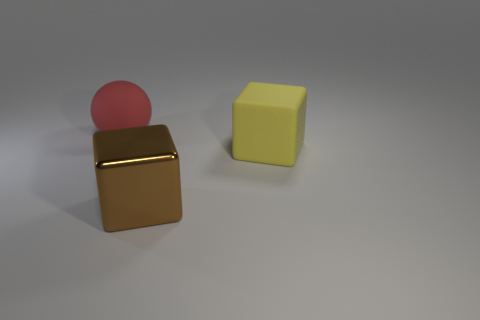How many red spheres are the same size as the yellow matte thing?
Offer a terse response. 1. Is the number of brown blocks that are on the right side of the yellow object the same as the number of large purple spheres?
Provide a short and direct response. Yes. How many large things are to the left of the yellow rubber object and behind the big brown metallic object?
Your response must be concise. 1. The block that is made of the same material as the ball is what size?
Ensure brevity in your answer.  Large. What number of other big objects have the same shape as the large red matte thing?
Offer a terse response. 0. Are there more big brown shiny objects right of the red matte sphere than green shiny things?
Make the answer very short. Yes. The thing that is both on the left side of the yellow matte thing and behind the big shiny cube has what shape?
Offer a very short reply. Sphere. Is the size of the metallic cube the same as the yellow object?
Provide a short and direct response. Yes. How many big rubber objects are in front of the red matte thing?
Your answer should be very brief. 1. Is the number of brown blocks to the right of the big yellow cube the same as the number of large blocks that are to the right of the red thing?
Your response must be concise. No. 